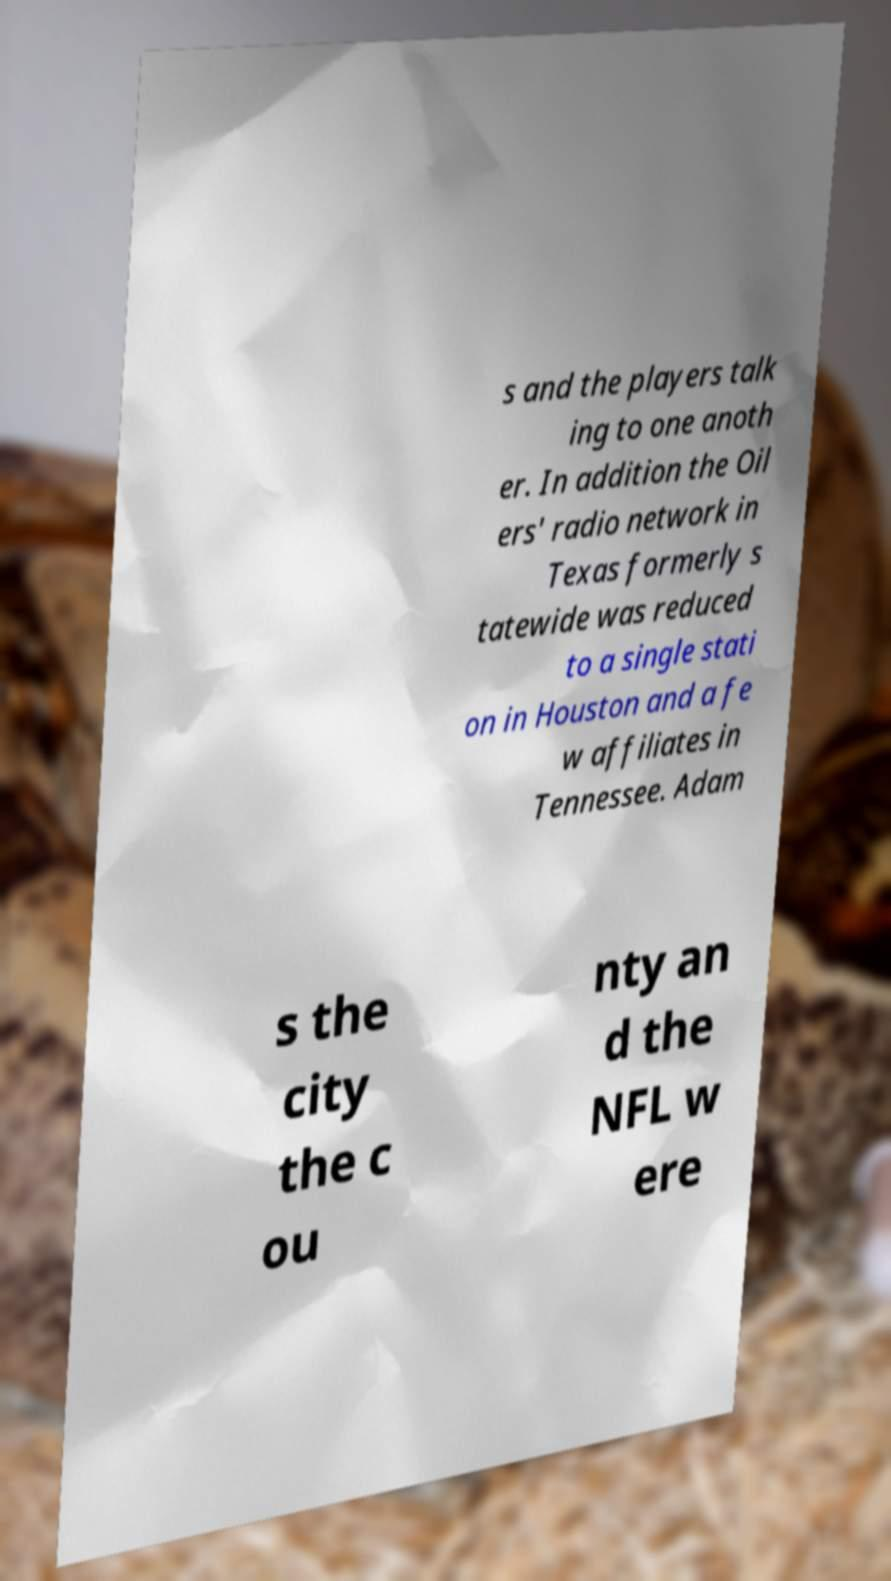Please read and relay the text visible in this image. What does it say? s and the players talk ing to one anoth er. In addition the Oil ers' radio network in Texas formerly s tatewide was reduced to a single stati on in Houston and a fe w affiliates in Tennessee. Adam s the city the c ou nty an d the NFL w ere 